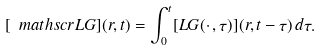Convert formula to latex. <formula><loc_0><loc_0><loc_500><loc_500>[ \ m a t h s c r { L } G ] ( r , t ) = \int _ { 0 } ^ { t } [ L G ( \cdot \, , \tau ) ] ( r , t - \tau ) \, d \tau .</formula> 